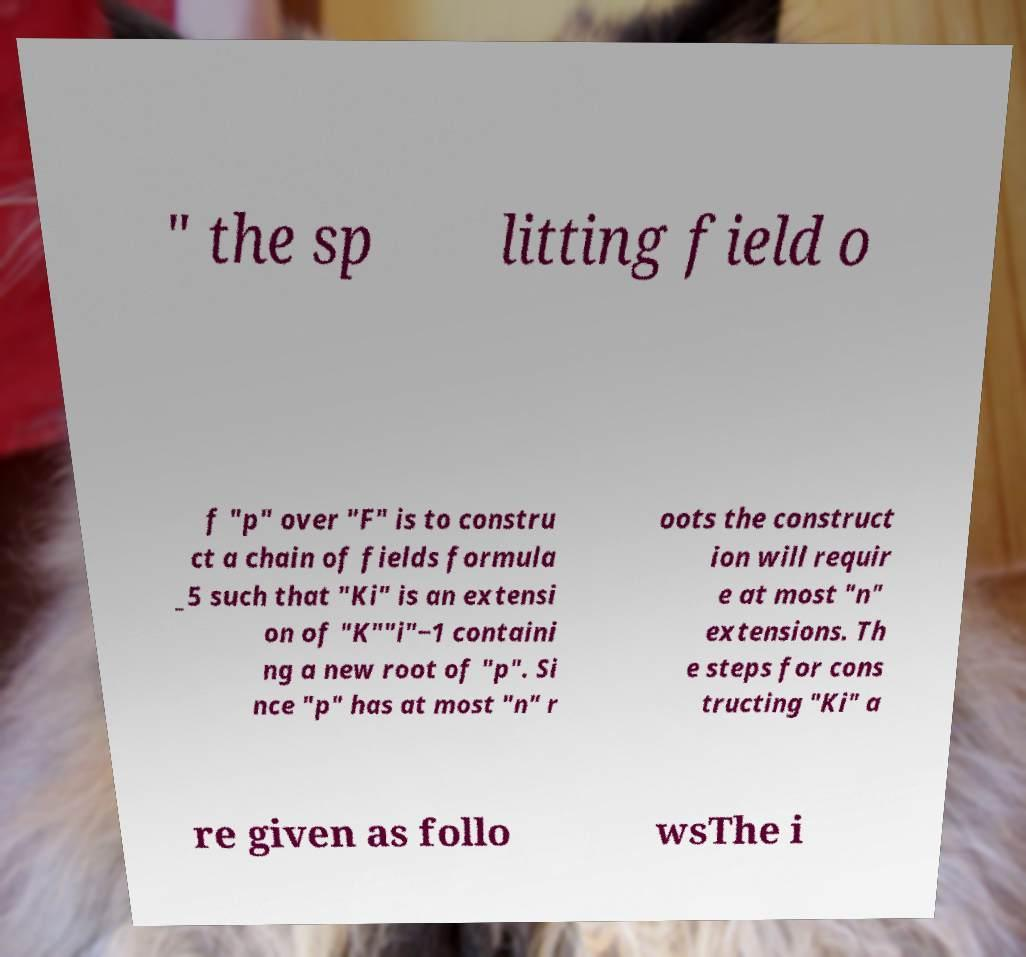Please identify and transcribe the text found in this image. " the sp litting field o f "p" over "F" is to constru ct a chain of fields formula _5 such that "Ki" is an extensi on of "K""i"−1 containi ng a new root of "p". Si nce "p" has at most "n" r oots the construct ion will requir e at most "n" extensions. Th e steps for cons tructing "Ki" a re given as follo wsThe i 